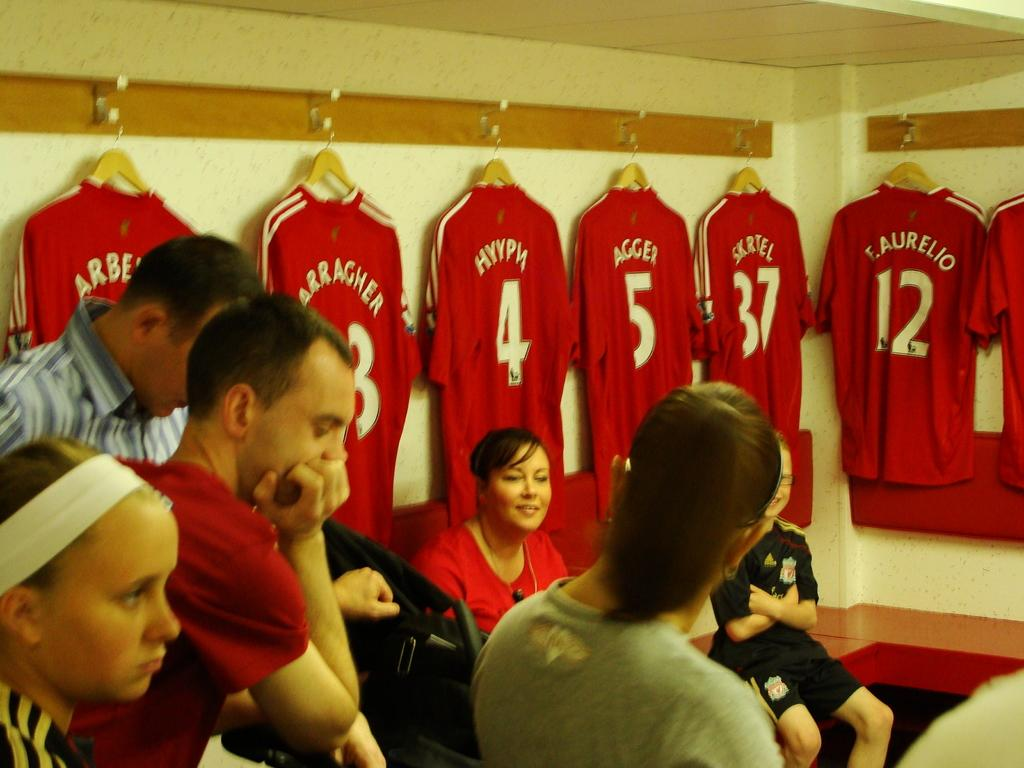Provide a one-sentence caption for the provided image. F. Aurelio is player #12 on the team. 